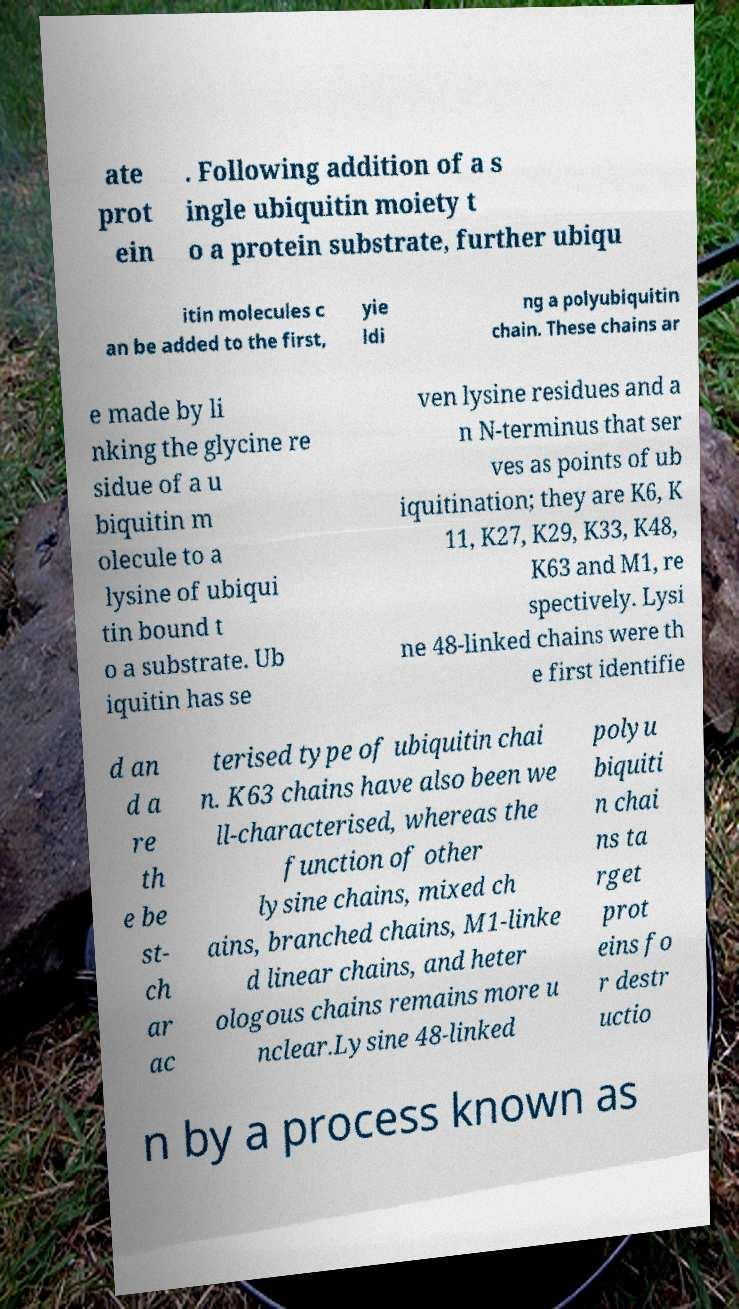I need the written content from this picture converted into text. Can you do that? ate prot ein . Following addition of a s ingle ubiquitin moiety t o a protein substrate, further ubiqu itin molecules c an be added to the first, yie ldi ng a polyubiquitin chain. These chains ar e made by li nking the glycine re sidue of a u biquitin m olecule to a lysine of ubiqui tin bound t o a substrate. Ub iquitin has se ven lysine residues and a n N-terminus that ser ves as points of ub iquitination; they are K6, K 11, K27, K29, K33, K48, K63 and M1, re spectively. Lysi ne 48-linked chains were th e first identifie d an d a re th e be st- ch ar ac terised type of ubiquitin chai n. K63 chains have also been we ll-characterised, whereas the function of other lysine chains, mixed ch ains, branched chains, M1-linke d linear chains, and heter ologous chains remains more u nclear.Lysine 48-linked polyu biquiti n chai ns ta rget prot eins fo r destr uctio n by a process known as 